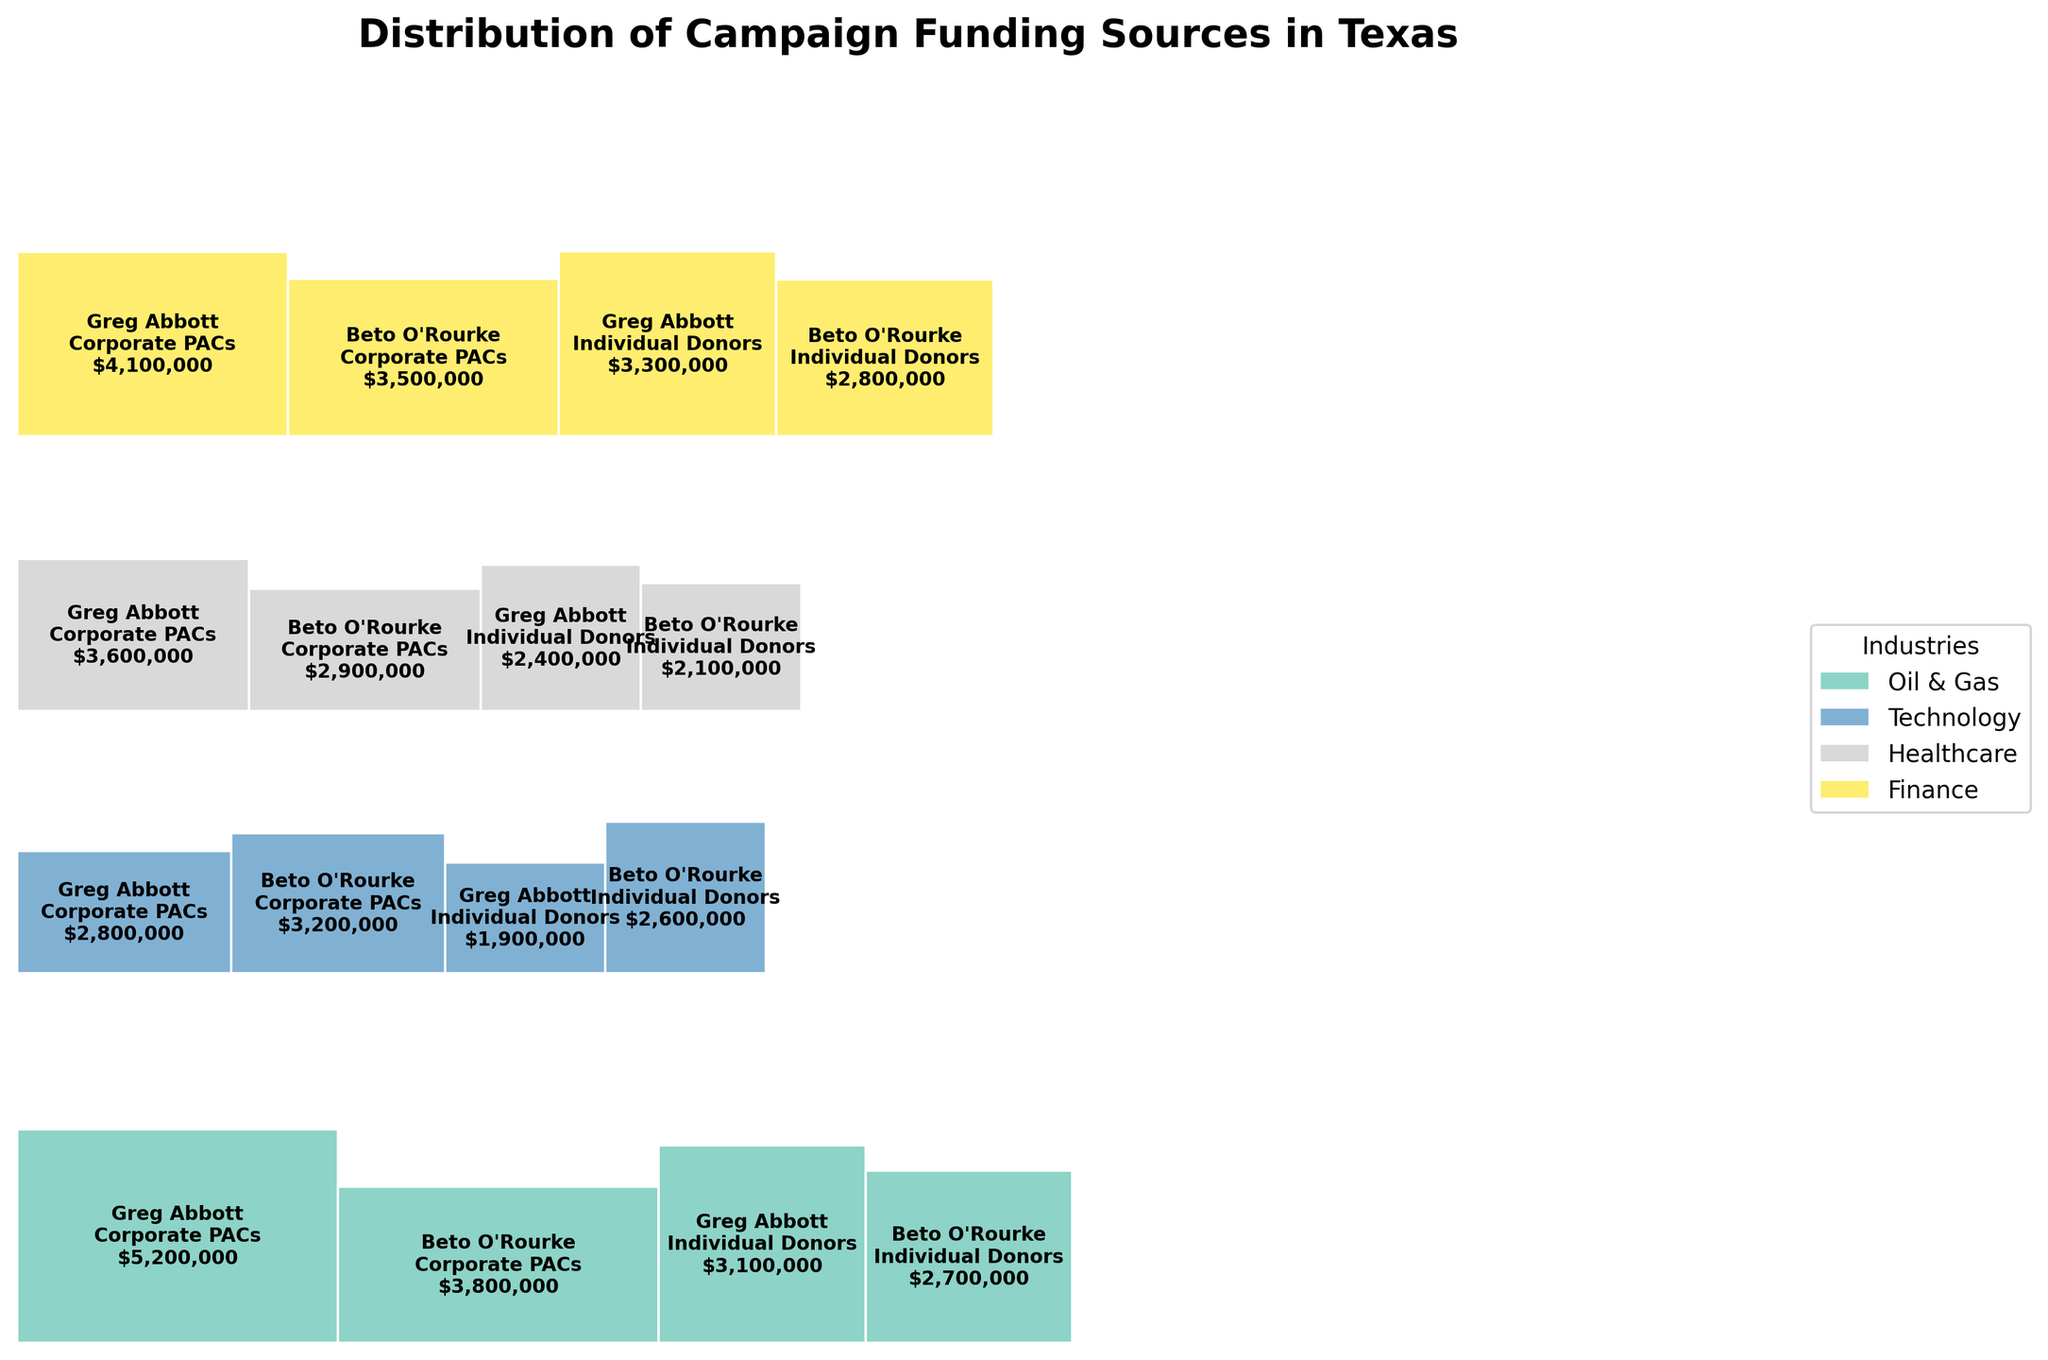What is the title of the plot? The title of the plot is displayed at the top of the figure, providing an overview of the subject matter.
Answer: Distribution of Campaign Funding Sources in Texas Which industry contributes the most to Greg Abbott's campaign from Corporate PACs? By observing the size of the rectangles representing Corporate PAC contributions to Greg Abbott, the largest rectangle corresponds to the Oil & Gas industry.
Answer: Oil & Gas Which candidate received more individual donations from the Healthcare industry? Compare the size of the rectangles for Healthcare individual donations for both candidates. Beto O'Rourke's corresponding rectangle is smaller than Greg Abbott's.
Answer: Greg Abbott In the Oil & Gas industry, who has a larger total campaign funding amount? Sum the contributions from both Corporate PACs and Individual Donors in the Oil & Gas industry for each candidate. Greg Abbott has $5,200,000 (Corporate PACs) + $3,100,000 (Individual Donors) = $8,300,000, while Beto O'Rourke has $3,800,000 + $2,700,000 = $6,500,000.
Answer: Greg Abbott Which donor type contributes more to the Technology industry? Aggregate the contributions from Corporate PACs and Individual Donors in the Technology industry for both candidates. Compare the size of the rectangles for both donor types. Corporate PACs have a larger combined contribution.
Answer: Corporate PACs Who received more total funding from Finance, Greg Abbott or Beto O'Rourke? Add the contributions from both Corporate PACs and Individual Donors in the Finance sector for each candidate. Greg Abbott received $4,100,000 (Corporate PACs) + $3,300,000 (Individual Donors) = $7,400,000. Beto O'Rourke received $3,500,000 + $2,800,000 = $6,300,000.
Answer: Greg Abbott Which industry provides the least amount of funding to both candidates combined? Sum the contributions from all sources for each industry and compare. Healthcare has the smallest combined contributions.
Answer: Healthcare For the Finance industry, which donor type provides more funding to Beto O'Rourke? Compare the rectangles representing Corporate PACs and Individual Donors within the Finance industry for Beto O'Rourke. The Corporate PACs rectangle is larger.
Answer: Corporate PACs Between Greg Abbott and Beto O'Rourke, who received more total campaign funding? Sum the contributions from all industries and donor types for each candidate. For Greg Abbott: $5,200,000 + $3,100,000 + $2,800,000 + $1,900,000 + $3,600,000 + $2,400,000 + $4,100,000 + $3,300,000 = $26,400,000. For Beto O'Rourke: $3,800,000 + $2,700,000 + $3,200,000 + $2,600,000 + $2,900,000 + $2,100,000 + $3,500,000 + $2,800,000 = $23,600,000.
Answer: Greg Abbott 